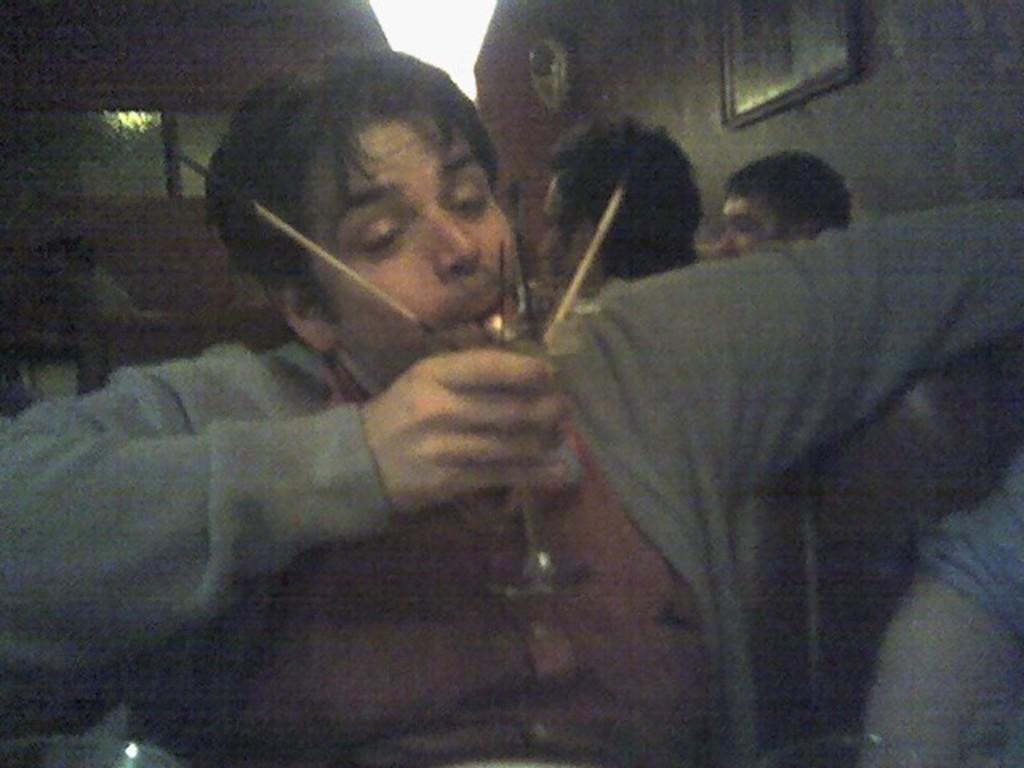How would you summarize this image in a sentence or two? In this image, we can see a man sitting and holding a glass, in the background there are some people sitting. 